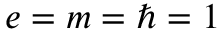<formula> <loc_0><loc_0><loc_500><loc_500>e = m = \hbar { = } 1</formula> 